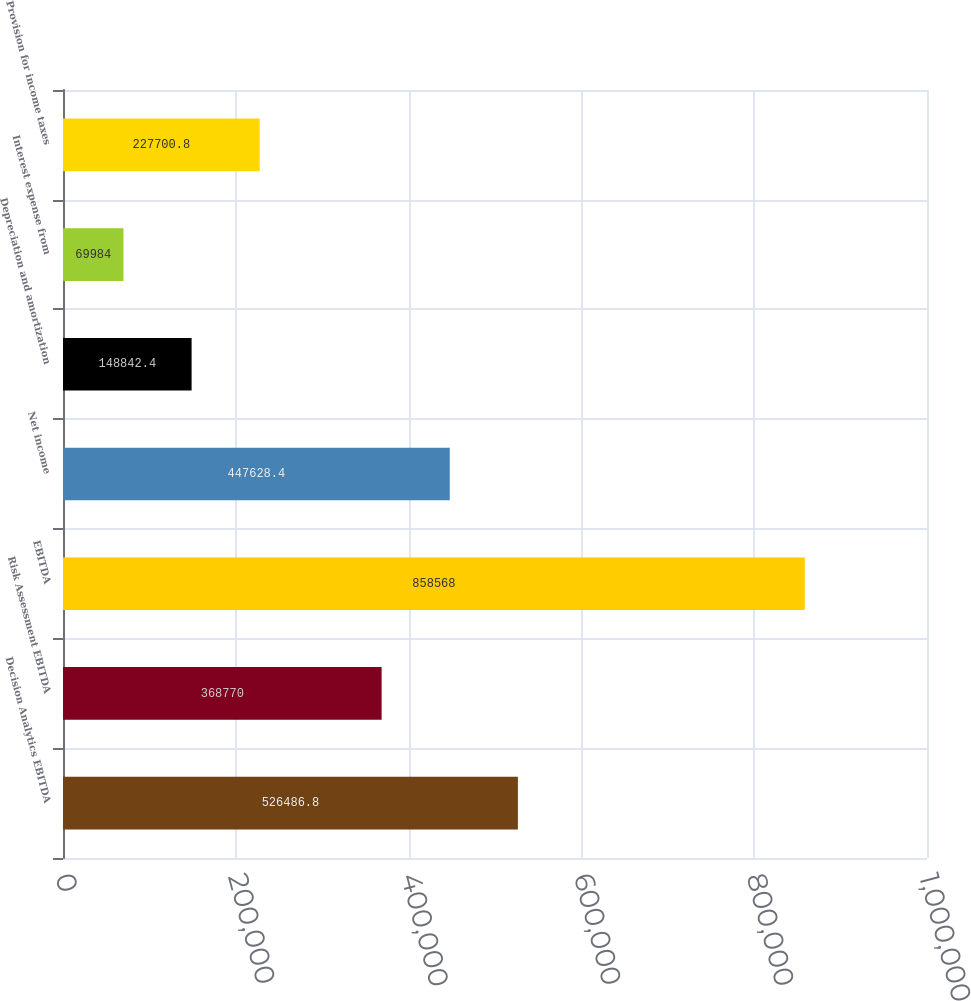Convert chart. <chart><loc_0><loc_0><loc_500><loc_500><bar_chart><fcel>Decision Analytics EBITDA<fcel>Risk Assessment EBITDA<fcel>EBITDA<fcel>Net income<fcel>Depreciation and amortization<fcel>Interest expense from<fcel>Provision for income taxes<nl><fcel>526487<fcel>368770<fcel>858568<fcel>447628<fcel>148842<fcel>69984<fcel>227701<nl></chart> 